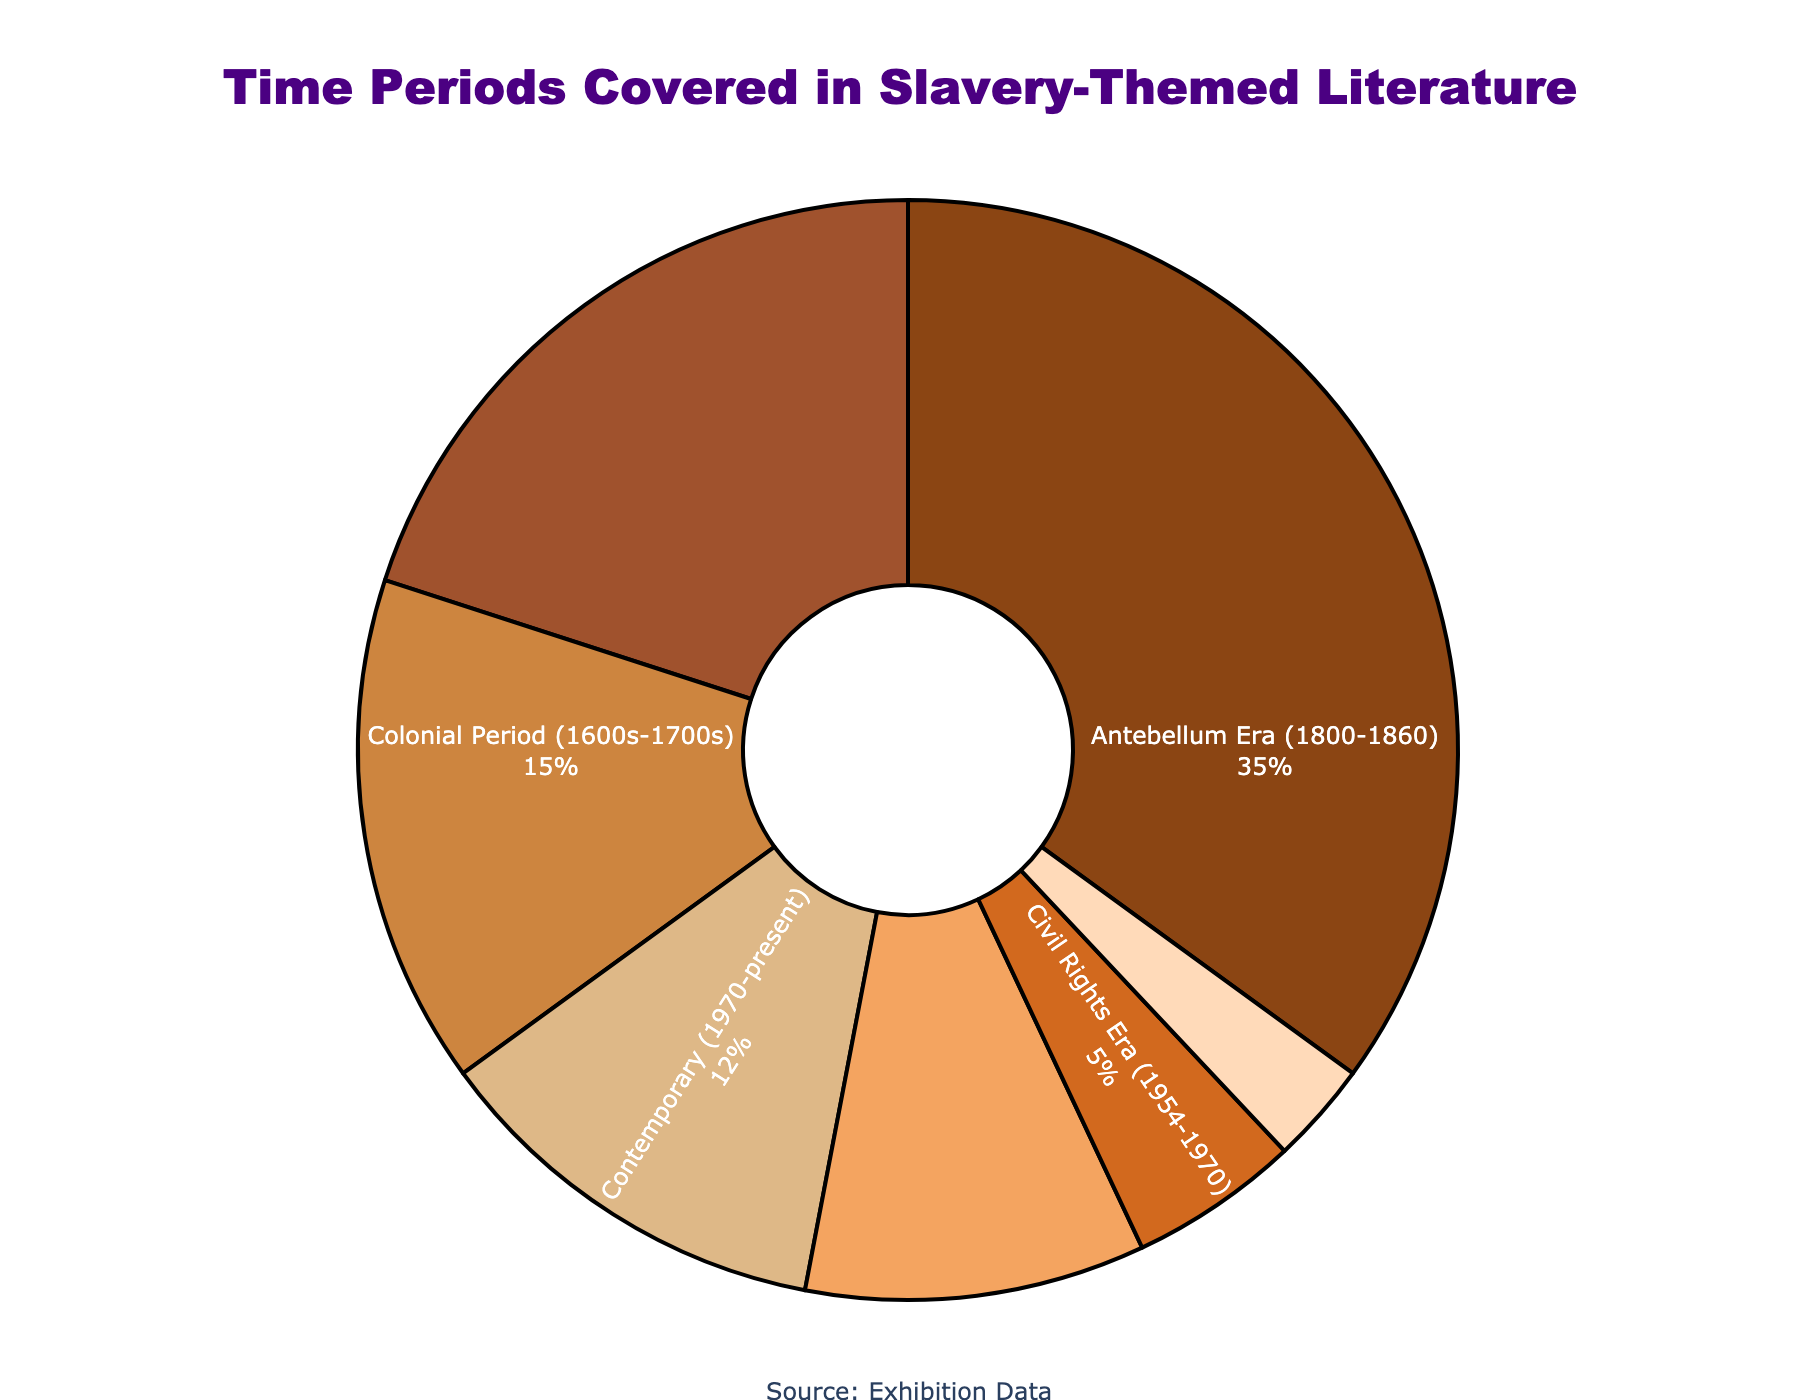Which time period is depicted the most in slavery-themed literature? The Antebellum Era (1800-1860) is shown to be the largest slice in the pie chart. It occupies 35% of the total distribution, making it the most depicted time period.
Answer: Antebellum Era (1800-1860) Which two time periods combined cover the least percentage of slavery-themed literature? The Civil Rights Era (1954-1970) and Ancient and Classical Civilizations slices together cover the least percentage. Their combined total is 5% + 3% = 8%.
Answer: Civil Rights Era (1954-1970) and Ancient and Classical Civilizations How does the percentage of literature depicting the Antebellum Era compare to that of the Post-Reconstruction/Jim Crow Era? The Antebellum Era occupies 35%, while the Post-Reconstruction/Jim Crow Era occupies only 10%. The Antebellum Era accounts for 25% more of the literature.
Answer: 25% more Which time period has the smallest depiction in slavery-themed literature? The Ancient and Classical Civilizations slice is the smallest in the pie chart, covering only 3% of the total distribution.
Answer: Ancient and Classical Civilizations What is the combined percentage of literature that depicts time periods before the 19th century? Summing up the percentages for Colonial Period (1600s-1700s) and Ancient and Classical Civilizations gives 15% + 3% = 18%.
Answer: 18% Is there a significant difference between the depiction of the Civil War and Reconstruction era and the Contemporary era? The Civil War and Reconstruction era depicts 20%, while the Contemporary era depicts 12%. The difference is 20% - 12% = 8%.
Answer: 8% Which periods occupy more than 10% of the total depictions each? The chart shows that Antebellum Era (35%), Civil War and Reconstruction (20%), Colonial Period (15%), Contemporary (12%), and Post-Reconstruction/Jim Crow Era (10%) all exceed 10%.
Answer: Antebellum Era, Civil War and Reconstruction, Colonial Period, Contemporary, Post-Reconstruction/Jim Crow Era What percentage of literature covers time periods from the 19th century onwards? To find this, add the percentages for Antebellum Era, Civil War and Reconstruction, Post-Reconstruction/Jim Crow Era, Civil Rights Era, and Contemporary: 35% + 20% + 10% + 5% + 12% = 82%.
Answer: 82% What color is used to represent the Colonial Period in the pie chart? The Colonial Period is represented in a brownish color (#CD853F), which visually appears as a light brown or tan.
Answer: Light brown or tan 